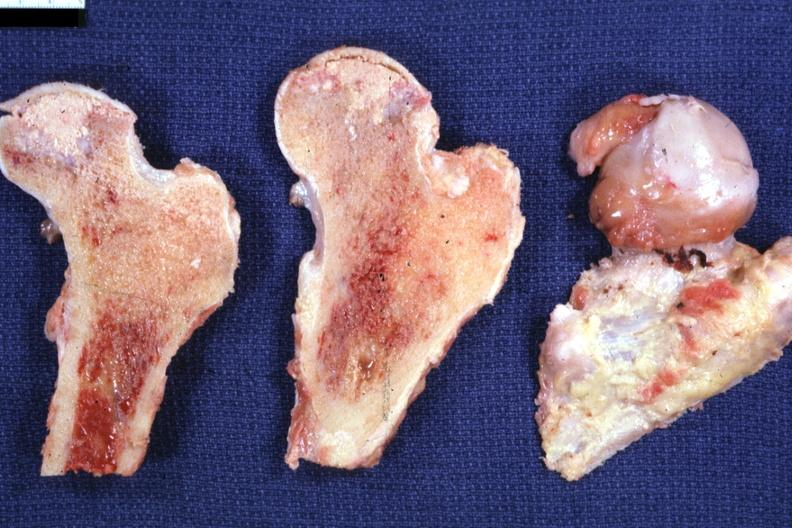does this image show sectioned femoral heads showing very nicely necrosis excellent?
Answer the question using a single word or phrase. Yes 